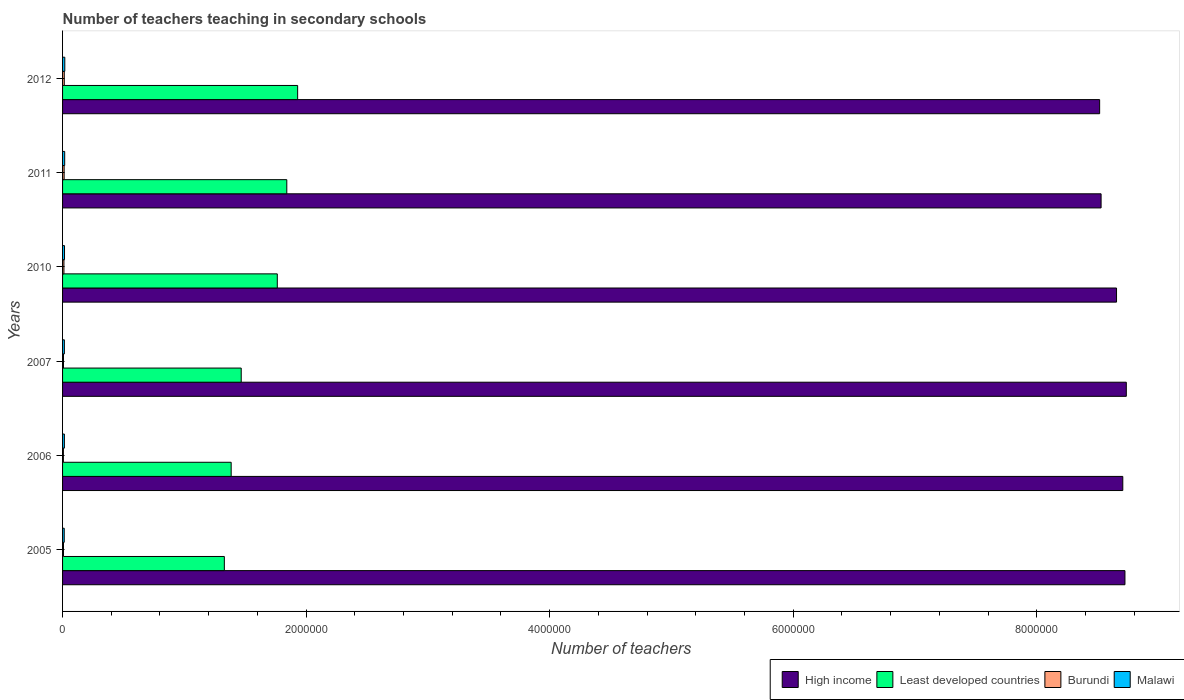How many different coloured bars are there?
Ensure brevity in your answer.  4. Are the number of bars per tick equal to the number of legend labels?
Offer a terse response. Yes. What is the label of the 1st group of bars from the top?
Offer a terse response. 2012. In how many cases, is the number of bars for a given year not equal to the number of legend labels?
Offer a very short reply. 0. What is the number of teachers teaching in secondary schools in High income in 2010?
Your response must be concise. 8.66e+06. Across all years, what is the maximum number of teachers teaching in secondary schools in Least developed countries?
Offer a terse response. 1.93e+06. Across all years, what is the minimum number of teachers teaching in secondary schools in Burundi?
Ensure brevity in your answer.  6770. What is the total number of teachers teaching in secondary schools in Malawi in the graph?
Provide a short and direct response. 9.53e+04. What is the difference between the number of teachers teaching in secondary schools in High income in 2007 and that in 2012?
Provide a short and direct response. 2.19e+05. What is the difference between the number of teachers teaching in secondary schools in High income in 2006 and the number of teachers teaching in secondary schools in Burundi in 2007?
Offer a terse response. 8.70e+06. What is the average number of teachers teaching in secondary schools in Malawi per year?
Ensure brevity in your answer.  1.59e+04. In the year 2012, what is the difference between the number of teachers teaching in secondary schools in Malawi and number of teachers teaching in secondary schools in Least developed countries?
Provide a short and direct response. -1.91e+06. In how many years, is the number of teachers teaching in secondary schools in Burundi greater than 7200000 ?
Keep it short and to the point. 0. What is the ratio of the number of teachers teaching in secondary schools in Malawi in 2011 to that in 2012?
Offer a very short reply. 0.95. Is the difference between the number of teachers teaching in secondary schools in Malawi in 2007 and 2010 greater than the difference between the number of teachers teaching in secondary schools in Least developed countries in 2007 and 2010?
Offer a very short reply. Yes. What is the difference between the highest and the second highest number of teachers teaching in secondary schools in High income?
Make the answer very short. 1.10e+04. What is the difference between the highest and the lowest number of teachers teaching in secondary schools in Malawi?
Offer a terse response. 4677. What does the 2nd bar from the bottom in 2006 represents?
Offer a terse response. Least developed countries. Is it the case that in every year, the sum of the number of teachers teaching in secondary schools in Malawi and number of teachers teaching in secondary schools in Least developed countries is greater than the number of teachers teaching in secondary schools in Burundi?
Keep it short and to the point. Yes. How many years are there in the graph?
Keep it short and to the point. 6. What is the difference between two consecutive major ticks on the X-axis?
Provide a short and direct response. 2.00e+06. Are the values on the major ticks of X-axis written in scientific E-notation?
Offer a very short reply. No. How many legend labels are there?
Your response must be concise. 4. What is the title of the graph?
Ensure brevity in your answer.  Number of teachers teaching in secondary schools. What is the label or title of the X-axis?
Keep it short and to the point. Number of teachers. What is the label or title of the Y-axis?
Provide a succinct answer. Years. What is the Number of teachers in High income in 2005?
Make the answer very short. 8.72e+06. What is the Number of teachers of Least developed countries in 2005?
Provide a succinct answer. 1.33e+06. What is the Number of teachers in Burundi in 2005?
Your response must be concise. 7498. What is the Number of teachers in Malawi in 2005?
Offer a very short reply. 1.37e+04. What is the Number of teachers in High income in 2006?
Keep it short and to the point. 8.71e+06. What is the Number of teachers in Least developed countries in 2006?
Keep it short and to the point. 1.38e+06. What is the Number of teachers in Burundi in 2006?
Provide a short and direct response. 6770. What is the Number of teachers of Malawi in 2006?
Your answer should be compact. 1.49e+04. What is the Number of teachers in High income in 2007?
Give a very brief answer. 8.74e+06. What is the Number of teachers in Least developed countries in 2007?
Provide a short and direct response. 1.47e+06. What is the Number of teachers of Burundi in 2007?
Give a very brief answer. 7501. What is the Number of teachers in Malawi in 2007?
Offer a terse response. 1.49e+04. What is the Number of teachers of High income in 2010?
Keep it short and to the point. 8.66e+06. What is the Number of teachers of Least developed countries in 2010?
Make the answer very short. 1.76e+06. What is the Number of teachers of Burundi in 2010?
Your answer should be compact. 1.13e+04. What is the Number of teachers of Malawi in 2010?
Give a very brief answer. 1.60e+04. What is the Number of teachers in High income in 2011?
Your answer should be very brief. 8.53e+06. What is the Number of teachers in Least developed countries in 2011?
Provide a short and direct response. 1.84e+06. What is the Number of teachers in Burundi in 2011?
Offer a terse response. 1.30e+04. What is the Number of teachers in Malawi in 2011?
Offer a very short reply. 1.75e+04. What is the Number of teachers in High income in 2012?
Make the answer very short. 8.52e+06. What is the Number of teachers of Least developed countries in 2012?
Give a very brief answer. 1.93e+06. What is the Number of teachers in Burundi in 2012?
Provide a succinct answer. 1.41e+04. What is the Number of teachers in Malawi in 2012?
Provide a short and direct response. 1.83e+04. Across all years, what is the maximum Number of teachers in High income?
Provide a succinct answer. 8.74e+06. Across all years, what is the maximum Number of teachers in Least developed countries?
Keep it short and to the point. 1.93e+06. Across all years, what is the maximum Number of teachers of Burundi?
Offer a very short reply. 1.41e+04. Across all years, what is the maximum Number of teachers in Malawi?
Offer a very short reply. 1.83e+04. Across all years, what is the minimum Number of teachers in High income?
Your answer should be compact. 8.52e+06. Across all years, what is the minimum Number of teachers in Least developed countries?
Ensure brevity in your answer.  1.33e+06. Across all years, what is the minimum Number of teachers of Burundi?
Keep it short and to the point. 6770. Across all years, what is the minimum Number of teachers of Malawi?
Offer a very short reply. 1.37e+04. What is the total Number of teachers of High income in the graph?
Ensure brevity in your answer.  5.19e+07. What is the total Number of teachers in Least developed countries in the graph?
Give a very brief answer. 9.72e+06. What is the total Number of teachers in Burundi in the graph?
Your answer should be compact. 6.02e+04. What is the total Number of teachers in Malawi in the graph?
Provide a short and direct response. 9.53e+04. What is the difference between the Number of teachers in High income in 2005 and that in 2006?
Provide a succinct answer. 1.78e+04. What is the difference between the Number of teachers of Least developed countries in 2005 and that in 2006?
Make the answer very short. -5.61e+04. What is the difference between the Number of teachers in Burundi in 2005 and that in 2006?
Ensure brevity in your answer.  728. What is the difference between the Number of teachers of Malawi in 2005 and that in 2006?
Provide a succinct answer. -1280. What is the difference between the Number of teachers in High income in 2005 and that in 2007?
Give a very brief answer. -1.10e+04. What is the difference between the Number of teachers of Least developed countries in 2005 and that in 2007?
Provide a short and direct response. -1.39e+05. What is the difference between the Number of teachers of Burundi in 2005 and that in 2007?
Your answer should be very brief. -3. What is the difference between the Number of teachers of Malawi in 2005 and that in 2007?
Your answer should be compact. -1254. What is the difference between the Number of teachers in High income in 2005 and that in 2010?
Ensure brevity in your answer.  6.92e+04. What is the difference between the Number of teachers of Least developed countries in 2005 and that in 2010?
Offer a very short reply. -4.35e+05. What is the difference between the Number of teachers in Burundi in 2005 and that in 2010?
Your answer should be very brief. -3777. What is the difference between the Number of teachers in Malawi in 2005 and that in 2010?
Provide a succinct answer. -2352. What is the difference between the Number of teachers of High income in 2005 and that in 2011?
Provide a succinct answer. 1.96e+05. What is the difference between the Number of teachers in Least developed countries in 2005 and that in 2011?
Offer a terse response. -5.13e+05. What is the difference between the Number of teachers in Burundi in 2005 and that in 2011?
Your response must be concise. -5470. What is the difference between the Number of teachers of Malawi in 2005 and that in 2011?
Give a very brief answer. -3820. What is the difference between the Number of teachers in High income in 2005 and that in 2012?
Keep it short and to the point. 2.08e+05. What is the difference between the Number of teachers of Least developed countries in 2005 and that in 2012?
Keep it short and to the point. -6.02e+05. What is the difference between the Number of teachers of Burundi in 2005 and that in 2012?
Offer a terse response. -6643. What is the difference between the Number of teachers of Malawi in 2005 and that in 2012?
Give a very brief answer. -4677. What is the difference between the Number of teachers of High income in 2006 and that in 2007?
Provide a succinct answer. -2.89e+04. What is the difference between the Number of teachers of Least developed countries in 2006 and that in 2007?
Keep it short and to the point. -8.26e+04. What is the difference between the Number of teachers in Burundi in 2006 and that in 2007?
Offer a terse response. -731. What is the difference between the Number of teachers in High income in 2006 and that in 2010?
Your answer should be very brief. 5.13e+04. What is the difference between the Number of teachers in Least developed countries in 2006 and that in 2010?
Your response must be concise. -3.79e+05. What is the difference between the Number of teachers of Burundi in 2006 and that in 2010?
Your answer should be compact. -4505. What is the difference between the Number of teachers in Malawi in 2006 and that in 2010?
Your answer should be compact. -1072. What is the difference between the Number of teachers in High income in 2006 and that in 2011?
Your answer should be compact. 1.78e+05. What is the difference between the Number of teachers in Least developed countries in 2006 and that in 2011?
Your answer should be compact. -4.57e+05. What is the difference between the Number of teachers in Burundi in 2006 and that in 2011?
Provide a succinct answer. -6198. What is the difference between the Number of teachers in Malawi in 2006 and that in 2011?
Make the answer very short. -2540. What is the difference between the Number of teachers in High income in 2006 and that in 2012?
Offer a very short reply. 1.90e+05. What is the difference between the Number of teachers in Least developed countries in 2006 and that in 2012?
Your answer should be very brief. -5.46e+05. What is the difference between the Number of teachers in Burundi in 2006 and that in 2012?
Offer a very short reply. -7371. What is the difference between the Number of teachers of Malawi in 2006 and that in 2012?
Your answer should be compact. -3397. What is the difference between the Number of teachers of High income in 2007 and that in 2010?
Make the answer very short. 8.02e+04. What is the difference between the Number of teachers of Least developed countries in 2007 and that in 2010?
Provide a short and direct response. -2.96e+05. What is the difference between the Number of teachers of Burundi in 2007 and that in 2010?
Keep it short and to the point. -3774. What is the difference between the Number of teachers of Malawi in 2007 and that in 2010?
Offer a very short reply. -1098. What is the difference between the Number of teachers of High income in 2007 and that in 2011?
Your answer should be very brief. 2.07e+05. What is the difference between the Number of teachers of Least developed countries in 2007 and that in 2011?
Provide a short and direct response. -3.74e+05. What is the difference between the Number of teachers in Burundi in 2007 and that in 2011?
Ensure brevity in your answer.  -5467. What is the difference between the Number of teachers of Malawi in 2007 and that in 2011?
Make the answer very short. -2566. What is the difference between the Number of teachers in High income in 2007 and that in 2012?
Make the answer very short. 2.19e+05. What is the difference between the Number of teachers of Least developed countries in 2007 and that in 2012?
Give a very brief answer. -4.63e+05. What is the difference between the Number of teachers of Burundi in 2007 and that in 2012?
Provide a short and direct response. -6640. What is the difference between the Number of teachers of Malawi in 2007 and that in 2012?
Provide a succinct answer. -3423. What is the difference between the Number of teachers in High income in 2010 and that in 2011?
Make the answer very short. 1.27e+05. What is the difference between the Number of teachers in Least developed countries in 2010 and that in 2011?
Your answer should be very brief. -7.80e+04. What is the difference between the Number of teachers in Burundi in 2010 and that in 2011?
Provide a succinct answer. -1693. What is the difference between the Number of teachers in Malawi in 2010 and that in 2011?
Give a very brief answer. -1468. What is the difference between the Number of teachers of High income in 2010 and that in 2012?
Your answer should be compact. 1.39e+05. What is the difference between the Number of teachers in Least developed countries in 2010 and that in 2012?
Your answer should be compact. -1.67e+05. What is the difference between the Number of teachers in Burundi in 2010 and that in 2012?
Keep it short and to the point. -2866. What is the difference between the Number of teachers of Malawi in 2010 and that in 2012?
Offer a very short reply. -2325. What is the difference between the Number of teachers of High income in 2011 and that in 2012?
Your answer should be very brief. 1.19e+04. What is the difference between the Number of teachers in Least developed countries in 2011 and that in 2012?
Your answer should be very brief. -8.90e+04. What is the difference between the Number of teachers of Burundi in 2011 and that in 2012?
Provide a succinct answer. -1173. What is the difference between the Number of teachers of Malawi in 2011 and that in 2012?
Provide a succinct answer. -857. What is the difference between the Number of teachers in High income in 2005 and the Number of teachers in Least developed countries in 2006?
Offer a very short reply. 7.34e+06. What is the difference between the Number of teachers in High income in 2005 and the Number of teachers in Burundi in 2006?
Offer a very short reply. 8.72e+06. What is the difference between the Number of teachers of High income in 2005 and the Number of teachers of Malawi in 2006?
Provide a short and direct response. 8.71e+06. What is the difference between the Number of teachers of Least developed countries in 2005 and the Number of teachers of Burundi in 2006?
Offer a terse response. 1.32e+06. What is the difference between the Number of teachers of Least developed countries in 2005 and the Number of teachers of Malawi in 2006?
Make the answer very short. 1.31e+06. What is the difference between the Number of teachers of Burundi in 2005 and the Number of teachers of Malawi in 2006?
Keep it short and to the point. -7441. What is the difference between the Number of teachers in High income in 2005 and the Number of teachers in Least developed countries in 2007?
Make the answer very short. 7.26e+06. What is the difference between the Number of teachers in High income in 2005 and the Number of teachers in Burundi in 2007?
Ensure brevity in your answer.  8.72e+06. What is the difference between the Number of teachers in High income in 2005 and the Number of teachers in Malawi in 2007?
Offer a very short reply. 8.71e+06. What is the difference between the Number of teachers of Least developed countries in 2005 and the Number of teachers of Burundi in 2007?
Offer a terse response. 1.32e+06. What is the difference between the Number of teachers of Least developed countries in 2005 and the Number of teachers of Malawi in 2007?
Make the answer very short. 1.31e+06. What is the difference between the Number of teachers of Burundi in 2005 and the Number of teachers of Malawi in 2007?
Offer a terse response. -7415. What is the difference between the Number of teachers of High income in 2005 and the Number of teachers of Least developed countries in 2010?
Give a very brief answer. 6.96e+06. What is the difference between the Number of teachers in High income in 2005 and the Number of teachers in Burundi in 2010?
Offer a terse response. 8.71e+06. What is the difference between the Number of teachers in High income in 2005 and the Number of teachers in Malawi in 2010?
Provide a short and direct response. 8.71e+06. What is the difference between the Number of teachers in Least developed countries in 2005 and the Number of teachers in Burundi in 2010?
Offer a terse response. 1.32e+06. What is the difference between the Number of teachers in Least developed countries in 2005 and the Number of teachers in Malawi in 2010?
Offer a very short reply. 1.31e+06. What is the difference between the Number of teachers of Burundi in 2005 and the Number of teachers of Malawi in 2010?
Your response must be concise. -8513. What is the difference between the Number of teachers of High income in 2005 and the Number of teachers of Least developed countries in 2011?
Your response must be concise. 6.88e+06. What is the difference between the Number of teachers of High income in 2005 and the Number of teachers of Burundi in 2011?
Offer a very short reply. 8.71e+06. What is the difference between the Number of teachers of High income in 2005 and the Number of teachers of Malawi in 2011?
Your answer should be compact. 8.71e+06. What is the difference between the Number of teachers of Least developed countries in 2005 and the Number of teachers of Burundi in 2011?
Keep it short and to the point. 1.32e+06. What is the difference between the Number of teachers in Least developed countries in 2005 and the Number of teachers in Malawi in 2011?
Your answer should be very brief. 1.31e+06. What is the difference between the Number of teachers in Burundi in 2005 and the Number of teachers in Malawi in 2011?
Provide a short and direct response. -9981. What is the difference between the Number of teachers in High income in 2005 and the Number of teachers in Least developed countries in 2012?
Make the answer very short. 6.79e+06. What is the difference between the Number of teachers of High income in 2005 and the Number of teachers of Burundi in 2012?
Provide a short and direct response. 8.71e+06. What is the difference between the Number of teachers of High income in 2005 and the Number of teachers of Malawi in 2012?
Your answer should be compact. 8.71e+06. What is the difference between the Number of teachers of Least developed countries in 2005 and the Number of teachers of Burundi in 2012?
Your response must be concise. 1.31e+06. What is the difference between the Number of teachers in Least developed countries in 2005 and the Number of teachers in Malawi in 2012?
Offer a very short reply. 1.31e+06. What is the difference between the Number of teachers in Burundi in 2005 and the Number of teachers in Malawi in 2012?
Keep it short and to the point. -1.08e+04. What is the difference between the Number of teachers of High income in 2006 and the Number of teachers of Least developed countries in 2007?
Your response must be concise. 7.24e+06. What is the difference between the Number of teachers in High income in 2006 and the Number of teachers in Burundi in 2007?
Your answer should be very brief. 8.70e+06. What is the difference between the Number of teachers of High income in 2006 and the Number of teachers of Malawi in 2007?
Keep it short and to the point. 8.69e+06. What is the difference between the Number of teachers of Least developed countries in 2006 and the Number of teachers of Burundi in 2007?
Offer a terse response. 1.38e+06. What is the difference between the Number of teachers of Least developed countries in 2006 and the Number of teachers of Malawi in 2007?
Your answer should be compact. 1.37e+06. What is the difference between the Number of teachers of Burundi in 2006 and the Number of teachers of Malawi in 2007?
Offer a terse response. -8143. What is the difference between the Number of teachers of High income in 2006 and the Number of teachers of Least developed countries in 2010?
Your answer should be very brief. 6.94e+06. What is the difference between the Number of teachers of High income in 2006 and the Number of teachers of Burundi in 2010?
Keep it short and to the point. 8.70e+06. What is the difference between the Number of teachers in High income in 2006 and the Number of teachers in Malawi in 2010?
Keep it short and to the point. 8.69e+06. What is the difference between the Number of teachers in Least developed countries in 2006 and the Number of teachers in Burundi in 2010?
Offer a very short reply. 1.37e+06. What is the difference between the Number of teachers in Least developed countries in 2006 and the Number of teachers in Malawi in 2010?
Give a very brief answer. 1.37e+06. What is the difference between the Number of teachers in Burundi in 2006 and the Number of teachers in Malawi in 2010?
Offer a very short reply. -9241. What is the difference between the Number of teachers in High income in 2006 and the Number of teachers in Least developed countries in 2011?
Provide a short and direct response. 6.87e+06. What is the difference between the Number of teachers of High income in 2006 and the Number of teachers of Burundi in 2011?
Provide a succinct answer. 8.69e+06. What is the difference between the Number of teachers in High income in 2006 and the Number of teachers in Malawi in 2011?
Make the answer very short. 8.69e+06. What is the difference between the Number of teachers of Least developed countries in 2006 and the Number of teachers of Burundi in 2011?
Provide a short and direct response. 1.37e+06. What is the difference between the Number of teachers of Least developed countries in 2006 and the Number of teachers of Malawi in 2011?
Provide a succinct answer. 1.37e+06. What is the difference between the Number of teachers in Burundi in 2006 and the Number of teachers in Malawi in 2011?
Keep it short and to the point. -1.07e+04. What is the difference between the Number of teachers in High income in 2006 and the Number of teachers in Least developed countries in 2012?
Your response must be concise. 6.78e+06. What is the difference between the Number of teachers of High income in 2006 and the Number of teachers of Burundi in 2012?
Offer a very short reply. 8.69e+06. What is the difference between the Number of teachers in High income in 2006 and the Number of teachers in Malawi in 2012?
Provide a succinct answer. 8.69e+06. What is the difference between the Number of teachers of Least developed countries in 2006 and the Number of teachers of Burundi in 2012?
Keep it short and to the point. 1.37e+06. What is the difference between the Number of teachers in Least developed countries in 2006 and the Number of teachers in Malawi in 2012?
Offer a very short reply. 1.37e+06. What is the difference between the Number of teachers of Burundi in 2006 and the Number of teachers of Malawi in 2012?
Keep it short and to the point. -1.16e+04. What is the difference between the Number of teachers in High income in 2007 and the Number of teachers in Least developed countries in 2010?
Make the answer very short. 6.97e+06. What is the difference between the Number of teachers in High income in 2007 and the Number of teachers in Burundi in 2010?
Your response must be concise. 8.72e+06. What is the difference between the Number of teachers in High income in 2007 and the Number of teachers in Malawi in 2010?
Your response must be concise. 8.72e+06. What is the difference between the Number of teachers in Least developed countries in 2007 and the Number of teachers in Burundi in 2010?
Your answer should be compact. 1.46e+06. What is the difference between the Number of teachers in Least developed countries in 2007 and the Number of teachers in Malawi in 2010?
Provide a succinct answer. 1.45e+06. What is the difference between the Number of teachers in Burundi in 2007 and the Number of teachers in Malawi in 2010?
Make the answer very short. -8510. What is the difference between the Number of teachers in High income in 2007 and the Number of teachers in Least developed countries in 2011?
Offer a terse response. 6.89e+06. What is the difference between the Number of teachers of High income in 2007 and the Number of teachers of Burundi in 2011?
Give a very brief answer. 8.72e+06. What is the difference between the Number of teachers in High income in 2007 and the Number of teachers in Malawi in 2011?
Your answer should be very brief. 8.72e+06. What is the difference between the Number of teachers in Least developed countries in 2007 and the Number of teachers in Burundi in 2011?
Offer a very short reply. 1.45e+06. What is the difference between the Number of teachers of Least developed countries in 2007 and the Number of teachers of Malawi in 2011?
Your answer should be very brief. 1.45e+06. What is the difference between the Number of teachers of Burundi in 2007 and the Number of teachers of Malawi in 2011?
Your answer should be compact. -9978. What is the difference between the Number of teachers in High income in 2007 and the Number of teachers in Least developed countries in 2012?
Make the answer very short. 6.81e+06. What is the difference between the Number of teachers in High income in 2007 and the Number of teachers in Burundi in 2012?
Your answer should be compact. 8.72e+06. What is the difference between the Number of teachers in High income in 2007 and the Number of teachers in Malawi in 2012?
Offer a terse response. 8.72e+06. What is the difference between the Number of teachers of Least developed countries in 2007 and the Number of teachers of Burundi in 2012?
Keep it short and to the point. 1.45e+06. What is the difference between the Number of teachers in Least developed countries in 2007 and the Number of teachers in Malawi in 2012?
Offer a terse response. 1.45e+06. What is the difference between the Number of teachers of Burundi in 2007 and the Number of teachers of Malawi in 2012?
Keep it short and to the point. -1.08e+04. What is the difference between the Number of teachers of High income in 2010 and the Number of teachers of Least developed countries in 2011?
Provide a short and direct response. 6.81e+06. What is the difference between the Number of teachers in High income in 2010 and the Number of teachers in Burundi in 2011?
Your response must be concise. 8.64e+06. What is the difference between the Number of teachers in High income in 2010 and the Number of teachers in Malawi in 2011?
Keep it short and to the point. 8.64e+06. What is the difference between the Number of teachers in Least developed countries in 2010 and the Number of teachers in Burundi in 2011?
Offer a terse response. 1.75e+06. What is the difference between the Number of teachers of Least developed countries in 2010 and the Number of teachers of Malawi in 2011?
Your answer should be very brief. 1.75e+06. What is the difference between the Number of teachers of Burundi in 2010 and the Number of teachers of Malawi in 2011?
Your answer should be very brief. -6204. What is the difference between the Number of teachers in High income in 2010 and the Number of teachers in Least developed countries in 2012?
Provide a succinct answer. 6.72e+06. What is the difference between the Number of teachers of High income in 2010 and the Number of teachers of Burundi in 2012?
Your answer should be very brief. 8.64e+06. What is the difference between the Number of teachers of High income in 2010 and the Number of teachers of Malawi in 2012?
Your answer should be compact. 8.64e+06. What is the difference between the Number of teachers in Least developed countries in 2010 and the Number of teachers in Burundi in 2012?
Your response must be concise. 1.75e+06. What is the difference between the Number of teachers of Least developed countries in 2010 and the Number of teachers of Malawi in 2012?
Provide a succinct answer. 1.75e+06. What is the difference between the Number of teachers in Burundi in 2010 and the Number of teachers in Malawi in 2012?
Keep it short and to the point. -7061. What is the difference between the Number of teachers of High income in 2011 and the Number of teachers of Least developed countries in 2012?
Give a very brief answer. 6.60e+06. What is the difference between the Number of teachers of High income in 2011 and the Number of teachers of Burundi in 2012?
Your answer should be compact. 8.51e+06. What is the difference between the Number of teachers in High income in 2011 and the Number of teachers in Malawi in 2012?
Offer a very short reply. 8.51e+06. What is the difference between the Number of teachers in Least developed countries in 2011 and the Number of teachers in Burundi in 2012?
Give a very brief answer. 1.83e+06. What is the difference between the Number of teachers of Least developed countries in 2011 and the Number of teachers of Malawi in 2012?
Your answer should be compact. 1.82e+06. What is the difference between the Number of teachers of Burundi in 2011 and the Number of teachers of Malawi in 2012?
Give a very brief answer. -5368. What is the average Number of teachers of High income per year?
Offer a very short reply. 8.64e+06. What is the average Number of teachers in Least developed countries per year?
Your response must be concise. 1.62e+06. What is the average Number of teachers of Burundi per year?
Ensure brevity in your answer.  1.00e+04. What is the average Number of teachers in Malawi per year?
Your answer should be very brief. 1.59e+04. In the year 2005, what is the difference between the Number of teachers of High income and Number of teachers of Least developed countries?
Offer a very short reply. 7.40e+06. In the year 2005, what is the difference between the Number of teachers of High income and Number of teachers of Burundi?
Your answer should be very brief. 8.72e+06. In the year 2005, what is the difference between the Number of teachers of High income and Number of teachers of Malawi?
Give a very brief answer. 8.71e+06. In the year 2005, what is the difference between the Number of teachers in Least developed countries and Number of teachers in Burundi?
Offer a terse response. 1.32e+06. In the year 2005, what is the difference between the Number of teachers of Least developed countries and Number of teachers of Malawi?
Your response must be concise. 1.31e+06. In the year 2005, what is the difference between the Number of teachers of Burundi and Number of teachers of Malawi?
Ensure brevity in your answer.  -6161. In the year 2006, what is the difference between the Number of teachers of High income and Number of teachers of Least developed countries?
Offer a very short reply. 7.32e+06. In the year 2006, what is the difference between the Number of teachers of High income and Number of teachers of Burundi?
Ensure brevity in your answer.  8.70e+06. In the year 2006, what is the difference between the Number of teachers of High income and Number of teachers of Malawi?
Your answer should be very brief. 8.69e+06. In the year 2006, what is the difference between the Number of teachers of Least developed countries and Number of teachers of Burundi?
Offer a terse response. 1.38e+06. In the year 2006, what is the difference between the Number of teachers of Least developed countries and Number of teachers of Malawi?
Your response must be concise. 1.37e+06. In the year 2006, what is the difference between the Number of teachers in Burundi and Number of teachers in Malawi?
Your response must be concise. -8169. In the year 2007, what is the difference between the Number of teachers of High income and Number of teachers of Least developed countries?
Keep it short and to the point. 7.27e+06. In the year 2007, what is the difference between the Number of teachers in High income and Number of teachers in Burundi?
Your response must be concise. 8.73e+06. In the year 2007, what is the difference between the Number of teachers in High income and Number of teachers in Malawi?
Provide a succinct answer. 8.72e+06. In the year 2007, what is the difference between the Number of teachers of Least developed countries and Number of teachers of Burundi?
Offer a very short reply. 1.46e+06. In the year 2007, what is the difference between the Number of teachers in Least developed countries and Number of teachers in Malawi?
Ensure brevity in your answer.  1.45e+06. In the year 2007, what is the difference between the Number of teachers of Burundi and Number of teachers of Malawi?
Provide a succinct answer. -7412. In the year 2010, what is the difference between the Number of teachers in High income and Number of teachers in Least developed countries?
Your response must be concise. 6.89e+06. In the year 2010, what is the difference between the Number of teachers in High income and Number of teachers in Burundi?
Offer a terse response. 8.64e+06. In the year 2010, what is the difference between the Number of teachers in High income and Number of teachers in Malawi?
Offer a terse response. 8.64e+06. In the year 2010, what is the difference between the Number of teachers in Least developed countries and Number of teachers in Burundi?
Provide a short and direct response. 1.75e+06. In the year 2010, what is the difference between the Number of teachers of Least developed countries and Number of teachers of Malawi?
Ensure brevity in your answer.  1.75e+06. In the year 2010, what is the difference between the Number of teachers of Burundi and Number of teachers of Malawi?
Your answer should be very brief. -4736. In the year 2011, what is the difference between the Number of teachers in High income and Number of teachers in Least developed countries?
Your response must be concise. 6.69e+06. In the year 2011, what is the difference between the Number of teachers in High income and Number of teachers in Burundi?
Make the answer very short. 8.52e+06. In the year 2011, what is the difference between the Number of teachers in High income and Number of teachers in Malawi?
Make the answer very short. 8.51e+06. In the year 2011, what is the difference between the Number of teachers of Least developed countries and Number of teachers of Burundi?
Ensure brevity in your answer.  1.83e+06. In the year 2011, what is the difference between the Number of teachers of Least developed countries and Number of teachers of Malawi?
Your answer should be very brief. 1.82e+06. In the year 2011, what is the difference between the Number of teachers in Burundi and Number of teachers in Malawi?
Your answer should be very brief. -4511. In the year 2012, what is the difference between the Number of teachers of High income and Number of teachers of Least developed countries?
Your answer should be compact. 6.59e+06. In the year 2012, what is the difference between the Number of teachers in High income and Number of teachers in Burundi?
Provide a short and direct response. 8.50e+06. In the year 2012, what is the difference between the Number of teachers in High income and Number of teachers in Malawi?
Your answer should be compact. 8.50e+06. In the year 2012, what is the difference between the Number of teachers in Least developed countries and Number of teachers in Burundi?
Provide a short and direct response. 1.92e+06. In the year 2012, what is the difference between the Number of teachers of Least developed countries and Number of teachers of Malawi?
Provide a short and direct response. 1.91e+06. In the year 2012, what is the difference between the Number of teachers of Burundi and Number of teachers of Malawi?
Make the answer very short. -4195. What is the ratio of the Number of teachers of High income in 2005 to that in 2006?
Offer a terse response. 1. What is the ratio of the Number of teachers of Least developed countries in 2005 to that in 2006?
Provide a short and direct response. 0.96. What is the ratio of the Number of teachers in Burundi in 2005 to that in 2006?
Your response must be concise. 1.11. What is the ratio of the Number of teachers of Malawi in 2005 to that in 2006?
Make the answer very short. 0.91. What is the ratio of the Number of teachers of Least developed countries in 2005 to that in 2007?
Your answer should be very brief. 0.91. What is the ratio of the Number of teachers of Burundi in 2005 to that in 2007?
Offer a very short reply. 1. What is the ratio of the Number of teachers of Malawi in 2005 to that in 2007?
Offer a terse response. 0.92. What is the ratio of the Number of teachers in Least developed countries in 2005 to that in 2010?
Provide a short and direct response. 0.75. What is the ratio of the Number of teachers in Burundi in 2005 to that in 2010?
Your answer should be compact. 0.67. What is the ratio of the Number of teachers in Malawi in 2005 to that in 2010?
Provide a short and direct response. 0.85. What is the ratio of the Number of teachers of Least developed countries in 2005 to that in 2011?
Your response must be concise. 0.72. What is the ratio of the Number of teachers in Burundi in 2005 to that in 2011?
Offer a terse response. 0.58. What is the ratio of the Number of teachers of Malawi in 2005 to that in 2011?
Give a very brief answer. 0.78. What is the ratio of the Number of teachers in High income in 2005 to that in 2012?
Your response must be concise. 1.02. What is the ratio of the Number of teachers in Least developed countries in 2005 to that in 2012?
Give a very brief answer. 0.69. What is the ratio of the Number of teachers in Burundi in 2005 to that in 2012?
Keep it short and to the point. 0.53. What is the ratio of the Number of teachers of Malawi in 2005 to that in 2012?
Provide a succinct answer. 0.74. What is the ratio of the Number of teachers in High income in 2006 to that in 2007?
Offer a very short reply. 1. What is the ratio of the Number of teachers of Least developed countries in 2006 to that in 2007?
Your response must be concise. 0.94. What is the ratio of the Number of teachers of Burundi in 2006 to that in 2007?
Provide a succinct answer. 0.9. What is the ratio of the Number of teachers of High income in 2006 to that in 2010?
Offer a terse response. 1.01. What is the ratio of the Number of teachers in Least developed countries in 2006 to that in 2010?
Offer a terse response. 0.79. What is the ratio of the Number of teachers in Burundi in 2006 to that in 2010?
Ensure brevity in your answer.  0.6. What is the ratio of the Number of teachers of Malawi in 2006 to that in 2010?
Provide a succinct answer. 0.93. What is the ratio of the Number of teachers in High income in 2006 to that in 2011?
Your answer should be compact. 1.02. What is the ratio of the Number of teachers of Least developed countries in 2006 to that in 2011?
Keep it short and to the point. 0.75. What is the ratio of the Number of teachers in Burundi in 2006 to that in 2011?
Your response must be concise. 0.52. What is the ratio of the Number of teachers in Malawi in 2006 to that in 2011?
Your answer should be very brief. 0.85. What is the ratio of the Number of teachers of High income in 2006 to that in 2012?
Offer a terse response. 1.02. What is the ratio of the Number of teachers of Least developed countries in 2006 to that in 2012?
Your answer should be very brief. 0.72. What is the ratio of the Number of teachers in Burundi in 2006 to that in 2012?
Give a very brief answer. 0.48. What is the ratio of the Number of teachers of Malawi in 2006 to that in 2012?
Keep it short and to the point. 0.81. What is the ratio of the Number of teachers of High income in 2007 to that in 2010?
Ensure brevity in your answer.  1.01. What is the ratio of the Number of teachers of Least developed countries in 2007 to that in 2010?
Make the answer very short. 0.83. What is the ratio of the Number of teachers in Burundi in 2007 to that in 2010?
Give a very brief answer. 0.67. What is the ratio of the Number of teachers of Malawi in 2007 to that in 2010?
Offer a very short reply. 0.93. What is the ratio of the Number of teachers in High income in 2007 to that in 2011?
Offer a terse response. 1.02. What is the ratio of the Number of teachers of Least developed countries in 2007 to that in 2011?
Give a very brief answer. 0.8. What is the ratio of the Number of teachers in Burundi in 2007 to that in 2011?
Provide a succinct answer. 0.58. What is the ratio of the Number of teachers in Malawi in 2007 to that in 2011?
Provide a short and direct response. 0.85. What is the ratio of the Number of teachers of High income in 2007 to that in 2012?
Your answer should be very brief. 1.03. What is the ratio of the Number of teachers in Least developed countries in 2007 to that in 2012?
Your response must be concise. 0.76. What is the ratio of the Number of teachers in Burundi in 2007 to that in 2012?
Make the answer very short. 0.53. What is the ratio of the Number of teachers in Malawi in 2007 to that in 2012?
Provide a short and direct response. 0.81. What is the ratio of the Number of teachers of High income in 2010 to that in 2011?
Ensure brevity in your answer.  1.01. What is the ratio of the Number of teachers in Least developed countries in 2010 to that in 2011?
Offer a very short reply. 0.96. What is the ratio of the Number of teachers of Burundi in 2010 to that in 2011?
Offer a terse response. 0.87. What is the ratio of the Number of teachers in Malawi in 2010 to that in 2011?
Offer a terse response. 0.92. What is the ratio of the Number of teachers in High income in 2010 to that in 2012?
Give a very brief answer. 1.02. What is the ratio of the Number of teachers in Least developed countries in 2010 to that in 2012?
Provide a short and direct response. 0.91. What is the ratio of the Number of teachers in Burundi in 2010 to that in 2012?
Your answer should be compact. 0.8. What is the ratio of the Number of teachers of Malawi in 2010 to that in 2012?
Make the answer very short. 0.87. What is the ratio of the Number of teachers in High income in 2011 to that in 2012?
Provide a succinct answer. 1. What is the ratio of the Number of teachers in Least developed countries in 2011 to that in 2012?
Your response must be concise. 0.95. What is the ratio of the Number of teachers in Burundi in 2011 to that in 2012?
Your response must be concise. 0.92. What is the ratio of the Number of teachers in Malawi in 2011 to that in 2012?
Provide a succinct answer. 0.95. What is the difference between the highest and the second highest Number of teachers in High income?
Ensure brevity in your answer.  1.10e+04. What is the difference between the highest and the second highest Number of teachers in Least developed countries?
Offer a very short reply. 8.90e+04. What is the difference between the highest and the second highest Number of teachers in Burundi?
Your answer should be very brief. 1173. What is the difference between the highest and the second highest Number of teachers of Malawi?
Provide a short and direct response. 857. What is the difference between the highest and the lowest Number of teachers of High income?
Offer a very short reply. 2.19e+05. What is the difference between the highest and the lowest Number of teachers in Least developed countries?
Your response must be concise. 6.02e+05. What is the difference between the highest and the lowest Number of teachers in Burundi?
Provide a succinct answer. 7371. What is the difference between the highest and the lowest Number of teachers of Malawi?
Provide a succinct answer. 4677. 